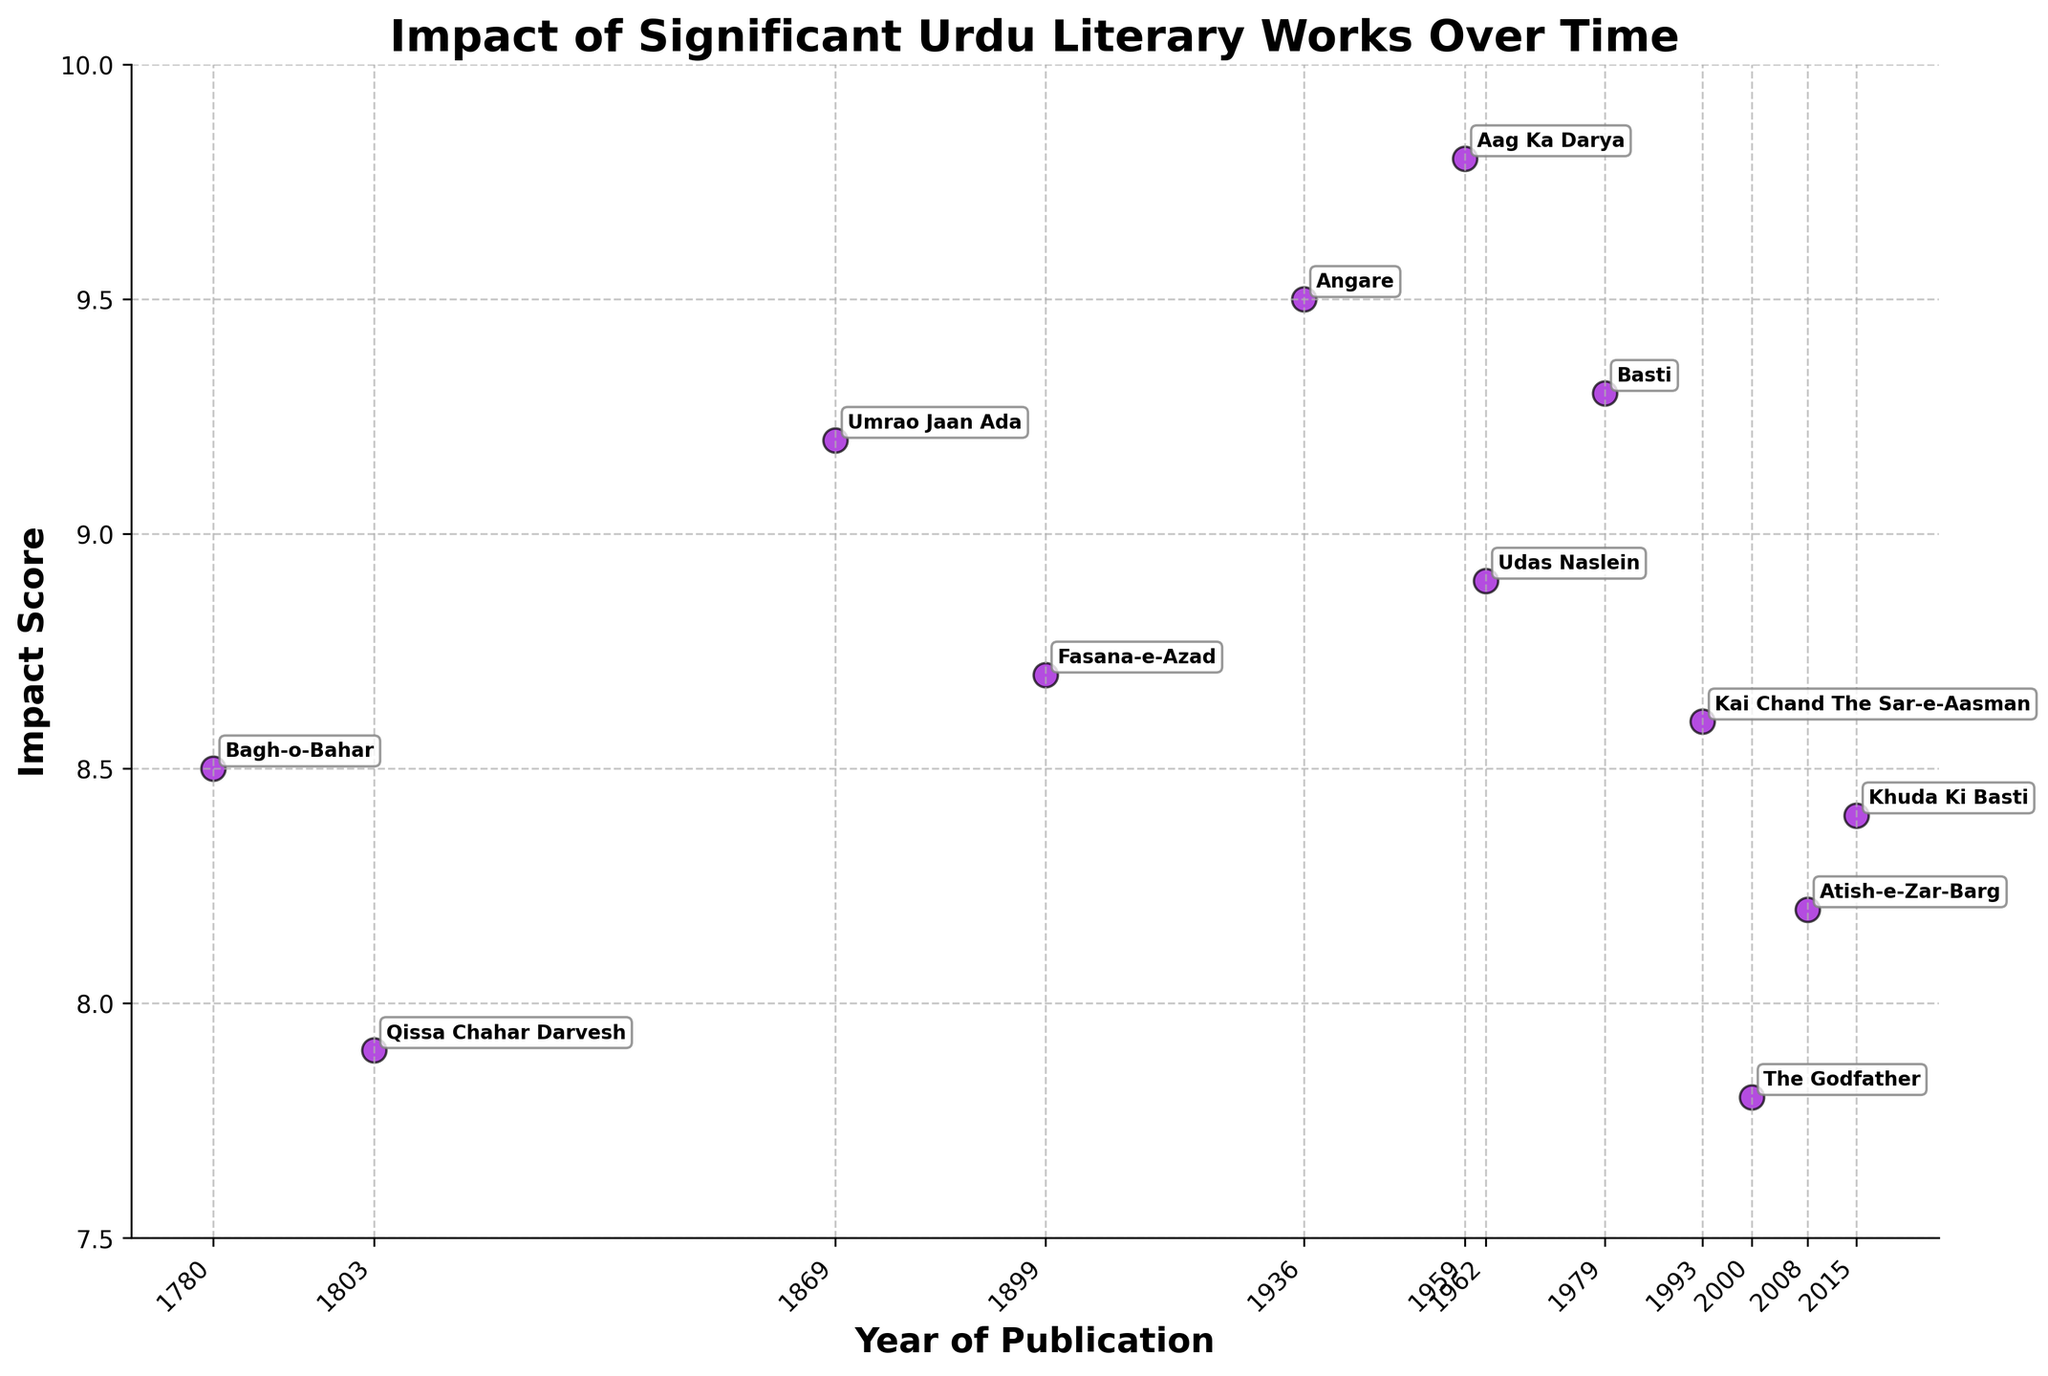What's the title of the plot? The title of the plot is directly indicated at the top of the figure. It reads "Impact of Significant Urdu Literary Works Over Time."
Answer: Impact of Significant Urdu Literary Works Over Time Which literary work has the highest impact score? The highest impact score can be identified by looking at the point that is farthest up on the y-axis. The point with the highest score is associated with "Aag Ka Darya," having an impact score of 9.8.
Answer: Aag Ka Darya Which year witnessed the publication of the literary work with the lowest impact score? The lowest impact score can be found by identifying the point that is closest to the bottom of the y-axis. The work is "The Godfather," published in 2000, with an impact score of 7.8.
Answer: 2000 How many literary works were published before the year 1900? To find the number of works published before 1900, look for points on the strip plot corresponding to years before 1900. The works are "Bagh-o-Bahar" (1780), "Qissa Chahar Darvesh" (1803), "Umrao Jaan Ada" (1869), and "Fasana-e-Azad" (1899). There are four such works.
Answer: 4 What are the impact scores of the literary works published in the 20th century (1901-2000)? To find the impact scores of works published in the 20th century, look for points corresponding to years between 1901 and 2000. The works are "Angare" (1936, 9.5), "Aag Ka Darya" (1959, 9.8), "Udas Naslein" (1962, 8.9), and "Basti" (1979, 9.3).
Answer: 9.5, 9.8, 8.9, 9.3 Which two consecutive literary works have the greatest difference in their impact scores? To find this, compare the impact scores of consecutive works for the largest difference. The pair "The Godfather" (2000, 7.8) and "Atish-e-Zar-Barg" (2008, 8.2) have a difference of 0.4, but "Angare" (1936, 9.5) and "Aag Ka Darya" (1959, 9.8) have only a difference of 0.3. The greatest difference is between consecutive works "Bagh-o-Bahar" (1780, 8.5) and "Qissa Chahar Darvesh" (1803, 7.9), with a difference of 0.6.
Answer: Bagh-o-Bahar and Qissa Chahar Darvesh What is the average impact score of the literary works published after 2000? Calculate the average for works published after 2000. The works are "Atish-e-Zar-Barg" (8.2) and "Khuda Ki Basti" (8.4). The average is (8.2 + 8.4) / 2 = 8.3.
Answer: 8.3 Which literary work published in the 21st century has the highest impact score? Identify works published after 2000 and compare their scores. The two works are "Atish-e-Zar-Barg" (8.2) and "Khuda Ki Basti" (8.4). The highest score among them is for "Khuda Ki Basti."
Answer: Khuda Ki Basti What visual attribute indicates the literary works' publication year distinctly? The x-axis of the strip plot explicitly shows the years of publication. The individual points are marked along this axis with their corresponding years displayed below.
Answer: X-axis labels Which decade in the 20th century has the highest number of influential literary works? Count the works per decade within the 20th century. For 1930-1939: "Angare" (1936) is one work. For 1950-1959: "Aag Ka Darya" (1959) is one work. For 1960-1969: "Udas Naslein" (1962) is one work. For 1970-1979: "Basti" (1979) is one work. Therefore, each of these decades has one influential work.
Answer: Each has 1 